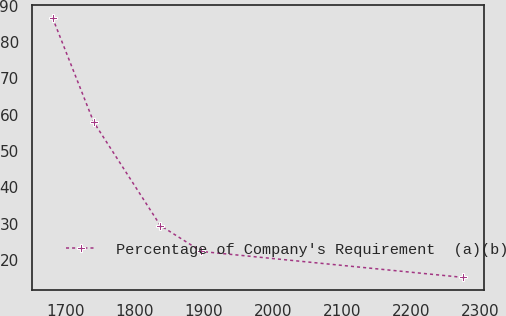Convert chart to OTSL. <chart><loc_0><loc_0><loc_500><loc_500><line_chart><ecel><fcel>Percentage of Company's Requirement  (a)(b)<nl><fcel>1680.98<fcel>86.67<nl><fcel>1740.45<fcel>58.02<nl><fcel>1837.02<fcel>29.54<nl><fcel>1896.49<fcel>22.4<nl><fcel>2275.7<fcel>15.26<nl></chart> 